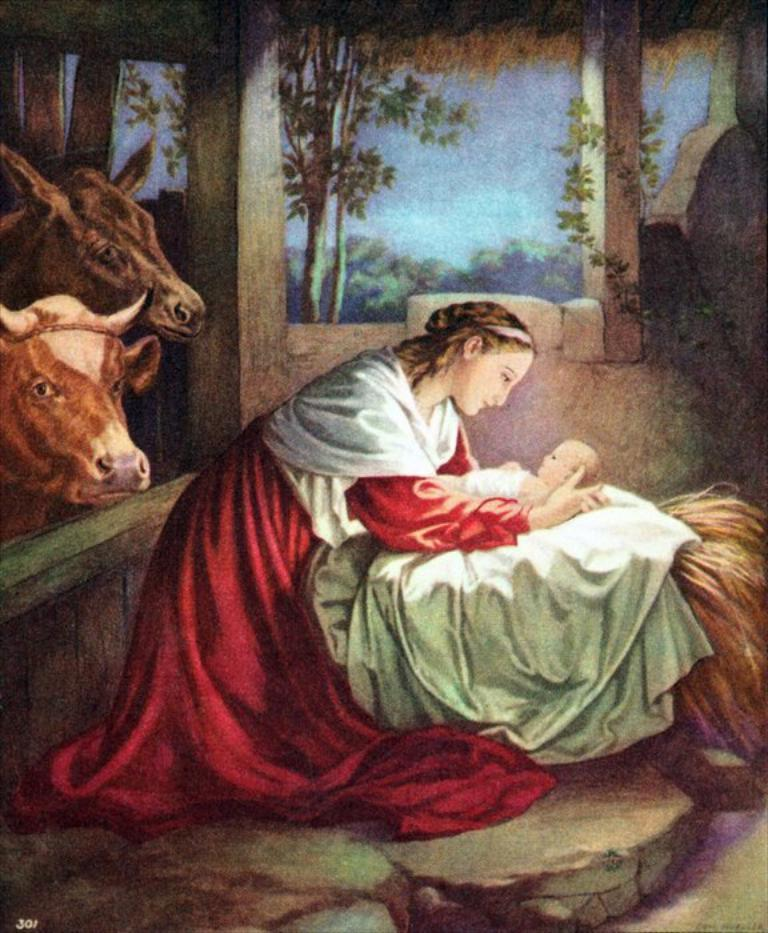What is depicted in the painting in the image? There is a painting of a woman in the image. What is the woman wearing in the painting? The woman is wearing a red dress in the painting. What is the woman holding in the painting? The woman is holding a baby in the painting. What can be seen on the left side of the image? There are cows on the left side of the image. What is visible in the background of the image? There is a wall and trees in the background of the image. What type of flowers can be seen in the image? There are no flowers present in the image. 